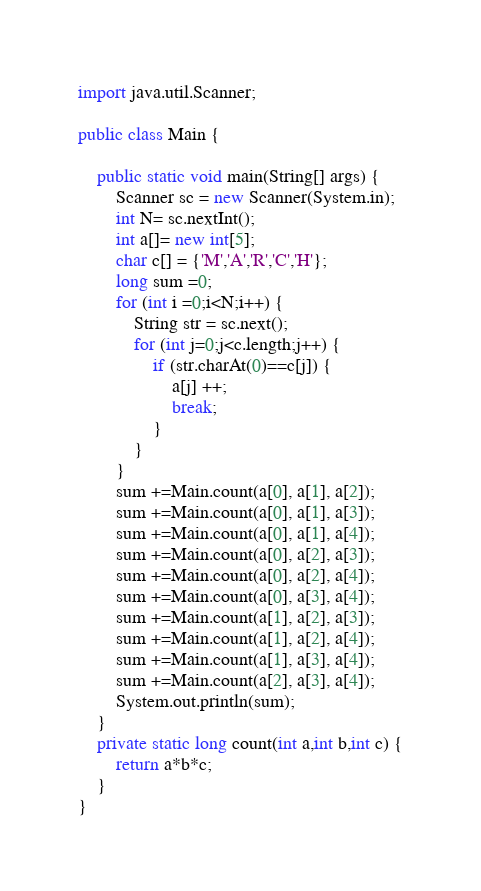Convert code to text. <code><loc_0><loc_0><loc_500><loc_500><_Java_>import java.util.Scanner;

public class Main {

	public static void main(String[] args) {
		Scanner sc = new Scanner(System.in);
		int N= sc.nextInt();
		int a[]= new int[5];
		char c[] = {'M','A','R','C','H'};
		long sum =0;
		for (int i =0;i<N;i++) {
			String str = sc.next();
			for (int j=0;j<c.length;j++) {
				if (str.charAt(0)==c[j]) {
					a[j] ++;
					break;
				}
			}
		}
		sum +=Main.count(a[0], a[1], a[2]);
		sum +=Main.count(a[0], a[1], a[3]);
		sum +=Main.count(a[0], a[1], a[4]);
		sum +=Main.count(a[0], a[2], a[3]);
		sum +=Main.count(a[0], a[2], a[4]);
		sum +=Main.count(a[0], a[3], a[4]);
		sum +=Main.count(a[1], a[2], a[3]);
		sum +=Main.count(a[1], a[2], a[4]);
		sum +=Main.count(a[1], a[3], a[4]);
		sum +=Main.count(a[2], a[3], a[4]);
		System.out.println(sum);
	}
	private static long count(int a,int b,int c) {
		return a*b*c;
	}
}</code> 